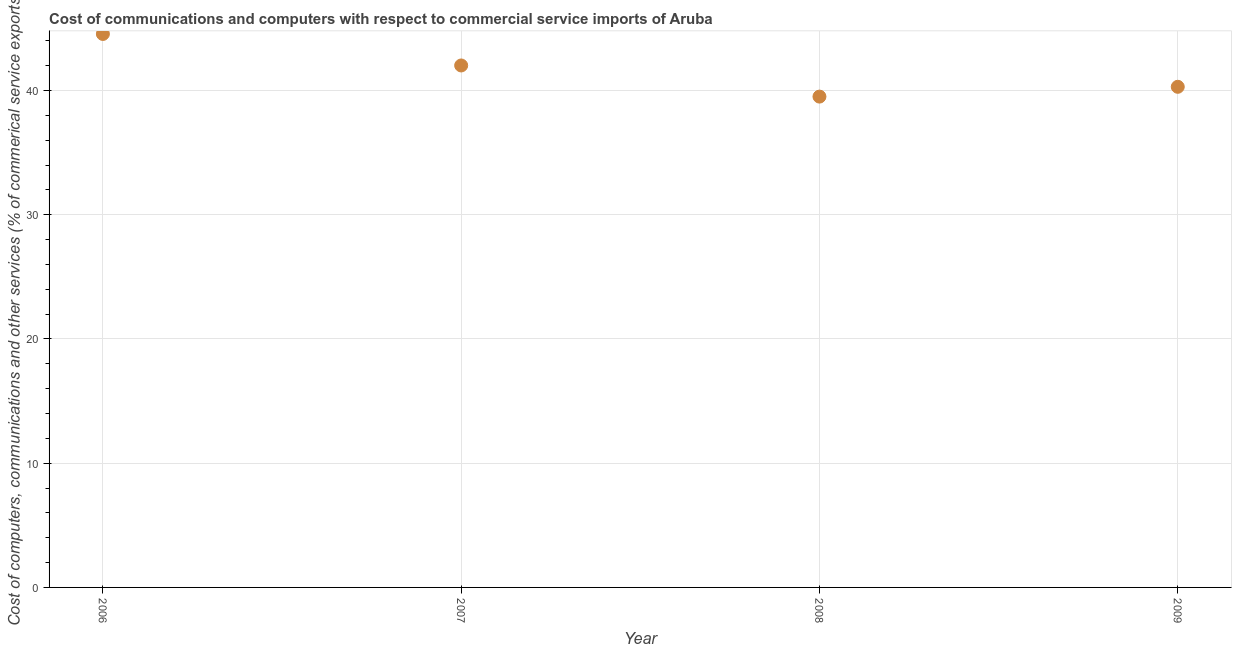What is the  computer and other services in 2008?
Your answer should be compact. 39.51. Across all years, what is the maximum  computer and other services?
Ensure brevity in your answer.  44.55. Across all years, what is the minimum  computer and other services?
Offer a very short reply. 39.51. In which year was the cost of communications maximum?
Your answer should be very brief. 2006. In which year was the  computer and other services minimum?
Make the answer very short. 2008. What is the sum of the  computer and other services?
Make the answer very short. 166.37. What is the difference between the  computer and other services in 2006 and 2007?
Provide a succinct answer. 2.54. What is the average  computer and other services per year?
Your answer should be very brief. 41.59. What is the median cost of communications?
Give a very brief answer. 41.16. Do a majority of the years between 2006 and 2008 (inclusive) have cost of communications greater than 8 %?
Provide a succinct answer. Yes. What is the ratio of the cost of communications in 2007 to that in 2009?
Make the answer very short. 1.04. Is the difference between the  computer and other services in 2007 and 2008 greater than the difference between any two years?
Provide a succinct answer. No. What is the difference between the highest and the second highest  computer and other services?
Offer a terse response. 2.54. Is the sum of the  computer and other services in 2008 and 2009 greater than the maximum  computer and other services across all years?
Your response must be concise. Yes. What is the difference between the highest and the lowest cost of communications?
Your answer should be very brief. 5.04. In how many years, is the  computer and other services greater than the average  computer and other services taken over all years?
Make the answer very short. 2. Does the  computer and other services monotonically increase over the years?
Provide a short and direct response. No. What is the difference between two consecutive major ticks on the Y-axis?
Ensure brevity in your answer.  10. Does the graph contain grids?
Make the answer very short. Yes. What is the title of the graph?
Your response must be concise. Cost of communications and computers with respect to commercial service imports of Aruba. What is the label or title of the Y-axis?
Your answer should be very brief. Cost of computers, communications and other services (% of commerical service exports). What is the Cost of computers, communications and other services (% of commerical service exports) in 2006?
Give a very brief answer. 44.55. What is the Cost of computers, communications and other services (% of commerical service exports) in 2007?
Provide a short and direct response. 42.01. What is the Cost of computers, communications and other services (% of commerical service exports) in 2008?
Your response must be concise. 39.51. What is the Cost of computers, communications and other services (% of commerical service exports) in 2009?
Make the answer very short. 40.3. What is the difference between the Cost of computers, communications and other services (% of commerical service exports) in 2006 and 2007?
Make the answer very short. 2.54. What is the difference between the Cost of computers, communications and other services (% of commerical service exports) in 2006 and 2008?
Offer a very short reply. 5.04. What is the difference between the Cost of computers, communications and other services (% of commerical service exports) in 2006 and 2009?
Your answer should be very brief. 4.25. What is the difference between the Cost of computers, communications and other services (% of commerical service exports) in 2007 and 2008?
Keep it short and to the point. 2.51. What is the difference between the Cost of computers, communications and other services (% of commerical service exports) in 2007 and 2009?
Provide a succinct answer. 1.72. What is the difference between the Cost of computers, communications and other services (% of commerical service exports) in 2008 and 2009?
Keep it short and to the point. -0.79. What is the ratio of the Cost of computers, communications and other services (% of commerical service exports) in 2006 to that in 2007?
Provide a succinct answer. 1.06. What is the ratio of the Cost of computers, communications and other services (% of commerical service exports) in 2006 to that in 2008?
Your answer should be very brief. 1.13. What is the ratio of the Cost of computers, communications and other services (% of commerical service exports) in 2006 to that in 2009?
Keep it short and to the point. 1.11. What is the ratio of the Cost of computers, communications and other services (% of commerical service exports) in 2007 to that in 2008?
Make the answer very short. 1.06. What is the ratio of the Cost of computers, communications and other services (% of commerical service exports) in 2007 to that in 2009?
Your answer should be very brief. 1.04. 